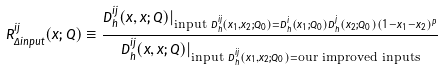<formula> <loc_0><loc_0><loc_500><loc_500>R ^ { i j } _ { \Delta i n p u t } ( x ; Q ) \equiv \frac { D _ { h } ^ { i j } ( x , x ; Q ) | _ { \text {input } D _ { h } ^ { i j } ( x _ { 1 } , x _ { 2 } ; Q _ { 0 } ) = D _ { h } ^ { i } ( x _ { 1 } ; Q _ { 0 } ) D _ { h } ^ { j } ( x _ { 2 } ; Q _ { 0 } ) ( 1 - x _ { 1 } - x _ { 2 } ) ^ { p } } } { D _ { h } ^ { i j } ( x , x ; Q ) | _ { \text {input } D _ { h } ^ { i j } ( x _ { 1 } , x _ { 2 } ; Q _ { 0 } ) = \text {our improved inputs} } }</formula> 